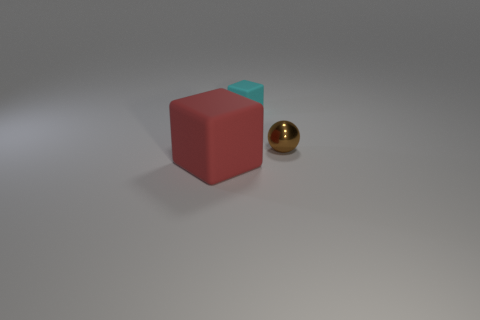Are there any brown things of the same shape as the big red thing?
Provide a short and direct response. No. How many things are either tiny things that are behind the small brown shiny ball or tiny cyan objects?
Keep it short and to the point. 1. The red block has what size?
Provide a short and direct response. Large. How many big objects are brown shiny spheres or metal cylinders?
Your answer should be very brief. 0. What is the color of the metal object that is the same size as the cyan matte object?
Give a very brief answer. Brown. How many other objects are the same shape as the brown metal object?
Make the answer very short. 0. Are there any other cubes that have the same material as the tiny cyan cube?
Ensure brevity in your answer.  Yes. Is the cube that is behind the red block made of the same material as the small object to the right of the tiny cyan rubber thing?
Your answer should be compact. No. How many large green matte cylinders are there?
Your answer should be very brief. 0. What shape is the tiny thing to the right of the cyan cube?
Offer a very short reply. Sphere. 